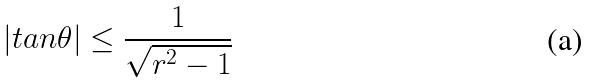Convert formula to latex. <formula><loc_0><loc_0><loc_500><loc_500>| t a n \theta | \leq \frac { 1 } { \sqrt { r ^ { 2 } - 1 } }</formula> 